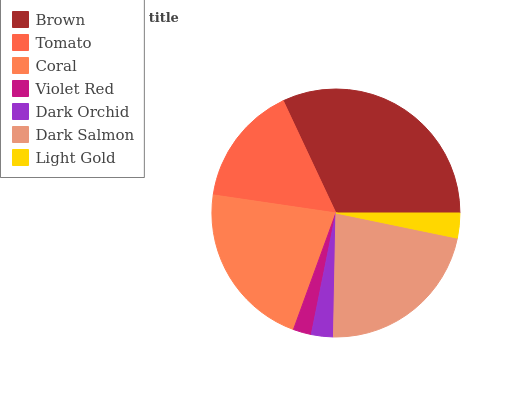Is Violet Red the minimum?
Answer yes or no. Yes. Is Brown the maximum?
Answer yes or no. Yes. Is Tomato the minimum?
Answer yes or no. No. Is Tomato the maximum?
Answer yes or no. No. Is Brown greater than Tomato?
Answer yes or no. Yes. Is Tomato less than Brown?
Answer yes or no. Yes. Is Tomato greater than Brown?
Answer yes or no. No. Is Brown less than Tomato?
Answer yes or no. No. Is Tomato the high median?
Answer yes or no. Yes. Is Tomato the low median?
Answer yes or no. Yes. Is Dark Salmon the high median?
Answer yes or no. No. Is Coral the low median?
Answer yes or no. No. 